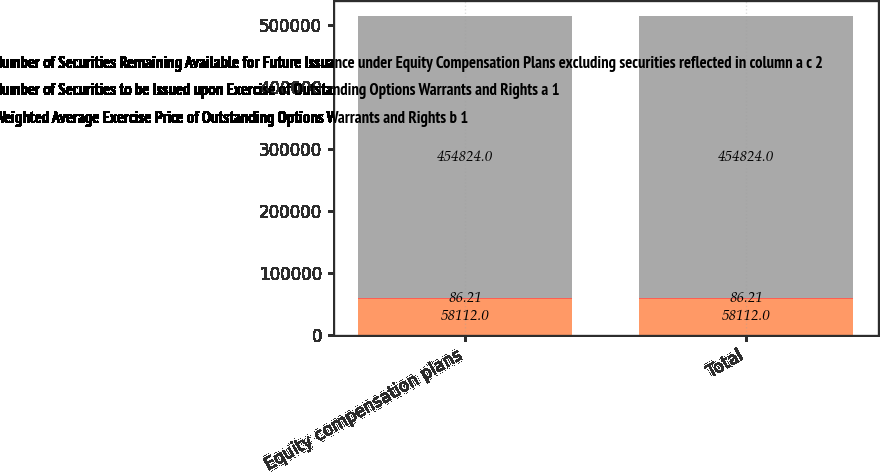Convert chart to OTSL. <chart><loc_0><loc_0><loc_500><loc_500><stacked_bar_chart><ecel><fcel>Equity compensation plans<fcel>Total<nl><fcel>Number of Securities Remaining Available for Future Issuance under Equity Compensation Plans excluding securities reflected in column a c 2<fcel>58112<fcel>58112<nl><fcel>Number of Securities to be Issued upon Exercise of Outstanding Options Warrants and Rights a 1<fcel>86.21<fcel>86.21<nl><fcel>Weighted Average Exercise Price of Outstanding Options Warrants and Rights b 1<fcel>454824<fcel>454824<nl></chart> 